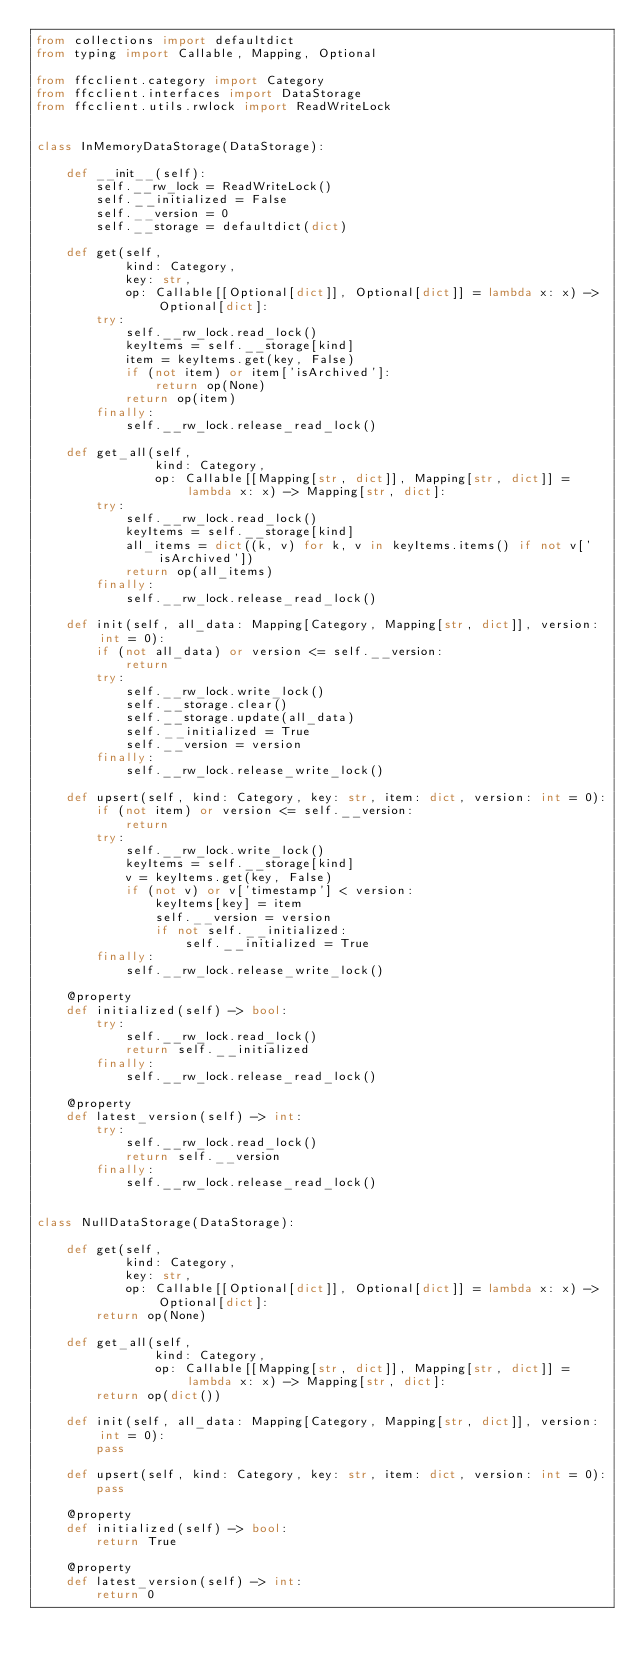Convert code to text. <code><loc_0><loc_0><loc_500><loc_500><_Python_>from collections import defaultdict
from typing import Callable, Mapping, Optional

from ffcclient.category import Category
from ffcclient.interfaces import DataStorage
from ffcclient.utils.rwlock import ReadWriteLock


class InMemoryDataStorage(DataStorage):

    def __init__(self):
        self.__rw_lock = ReadWriteLock()
        self.__initialized = False
        self.__version = 0
        self.__storage = defaultdict(dict)

    def get(self,
            kind: Category,
            key: str,
            op: Callable[[Optional[dict]], Optional[dict]] = lambda x: x) -> Optional[dict]:
        try:
            self.__rw_lock.read_lock()
            keyItems = self.__storage[kind]
            item = keyItems.get(key, False)
            if (not item) or item['isArchived']:
                return op(None)
            return op(item)
        finally:
            self.__rw_lock.release_read_lock()

    def get_all(self,
                kind: Category,
                op: Callable[[Mapping[str, dict]], Mapping[str, dict]] = lambda x: x) -> Mapping[str, dict]:
        try:
            self.__rw_lock.read_lock()
            keyItems = self.__storage[kind]
            all_items = dict((k, v) for k, v in keyItems.items() if not v['isArchived'])
            return op(all_items)
        finally:
            self.__rw_lock.release_read_lock()

    def init(self, all_data: Mapping[Category, Mapping[str, dict]], version: int = 0):
        if (not all_data) or version <= self.__version:
            return
        try:
            self.__rw_lock.write_lock()
            self.__storage.clear()
            self.__storage.update(all_data)
            self.__initialized = True
            self.__version = version
        finally:
            self.__rw_lock.release_write_lock()

    def upsert(self, kind: Category, key: str, item: dict, version: int = 0):
        if (not item) or version <= self.__version:
            return
        try:
            self.__rw_lock.write_lock()
            keyItems = self.__storage[kind]
            v = keyItems.get(key, False)
            if (not v) or v['timestamp'] < version:
                keyItems[key] = item
                self.__version = version
                if not self.__initialized:
                    self.__initialized = True
        finally:
            self.__rw_lock.release_write_lock()

    @property
    def initialized(self) -> bool:
        try:
            self.__rw_lock.read_lock()
            return self.__initialized
        finally:
            self.__rw_lock.release_read_lock()

    @property
    def latest_version(self) -> int:
        try:
            self.__rw_lock.read_lock()
            return self.__version
        finally:
            self.__rw_lock.release_read_lock()


class NullDataStorage(DataStorage):

    def get(self,
            kind: Category,
            key: str,
            op: Callable[[Optional[dict]], Optional[dict]] = lambda x: x) -> Optional[dict]:
        return op(None)

    def get_all(self,
                kind: Category,
                op: Callable[[Mapping[str, dict]], Mapping[str, dict]] = lambda x: x) -> Mapping[str, dict]:
        return op(dict())

    def init(self, all_data: Mapping[Category, Mapping[str, dict]], version: int = 0):
        pass

    def upsert(self, kind: Category, key: str, item: dict, version: int = 0):
        pass

    @property
    def initialized(self) -> bool:
        return True

    @property
    def latest_version(self) -> int:
        return 0
</code> 